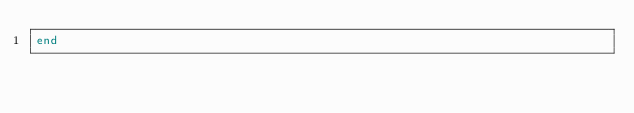Convert code to text. <code><loc_0><loc_0><loc_500><loc_500><_Ruby_>end
</code> 